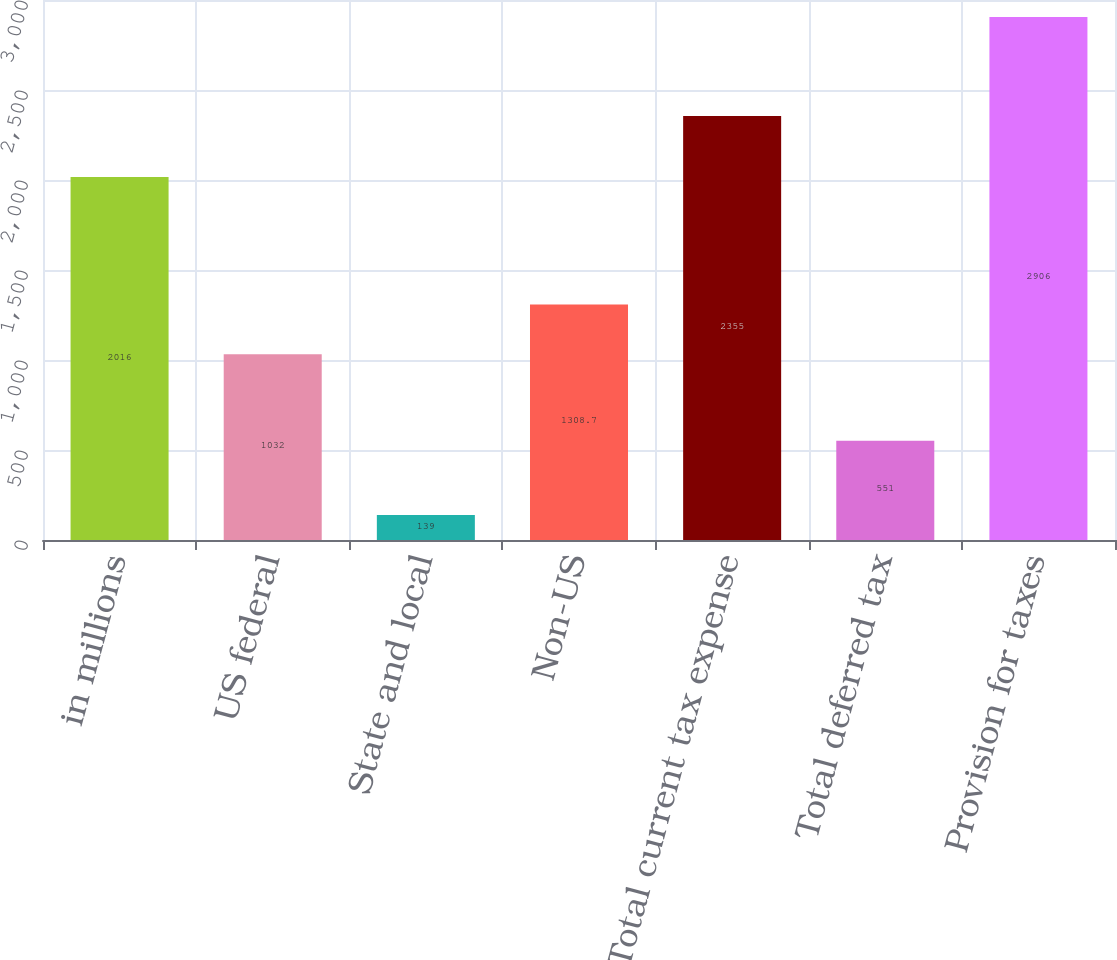<chart> <loc_0><loc_0><loc_500><loc_500><bar_chart><fcel>in millions<fcel>US federal<fcel>State and local<fcel>Non-US<fcel>Total current tax expense<fcel>Total deferred tax<fcel>Provision for taxes<nl><fcel>2016<fcel>1032<fcel>139<fcel>1308.7<fcel>2355<fcel>551<fcel>2906<nl></chart> 